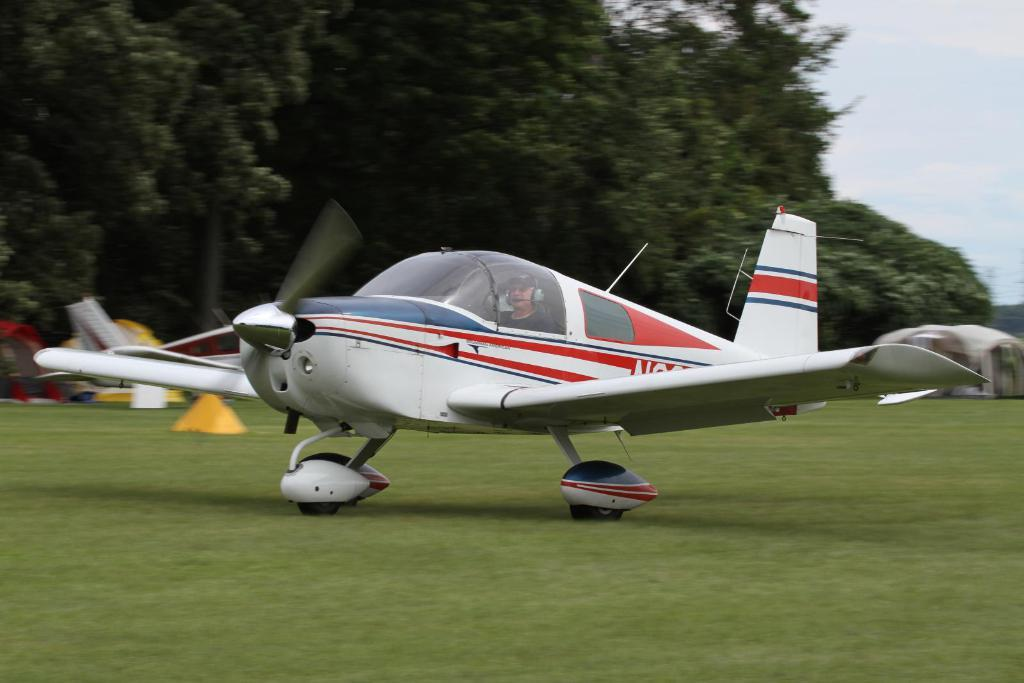What is the man in the image doing? The man is sitting inside an airplane. Where is the airplane located? The airplane is on the grassland. What can be seen on the left side of the image? There are trees on the left side of the image. What is visible above the image? The sky is visible above the image. What is the price of the silk linen in the image? There is no mention of silk linen or any price in the image. 